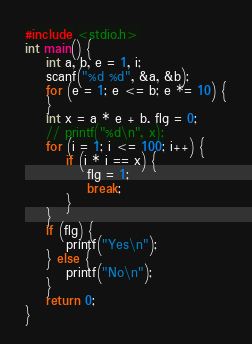<code> <loc_0><loc_0><loc_500><loc_500><_C_>#include <stdio.h>
int main() {
    int a, b, e = 1, i;
    scanf("%d %d", &a, &b);
    for (e = 1; e <= b; e *= 10) {
    }
    int x = a * e + b, flg = 0;
    // printf("%d\n", x);
    for (i = 1; i <= 100; i++) {
        if (i * i == x) {
            flg = 1;
            break;
        }
    }
    if (flg) {
        printf("Yes\n");
    } else {
        printf("No\n");
    }
    return 0;
}</code> 